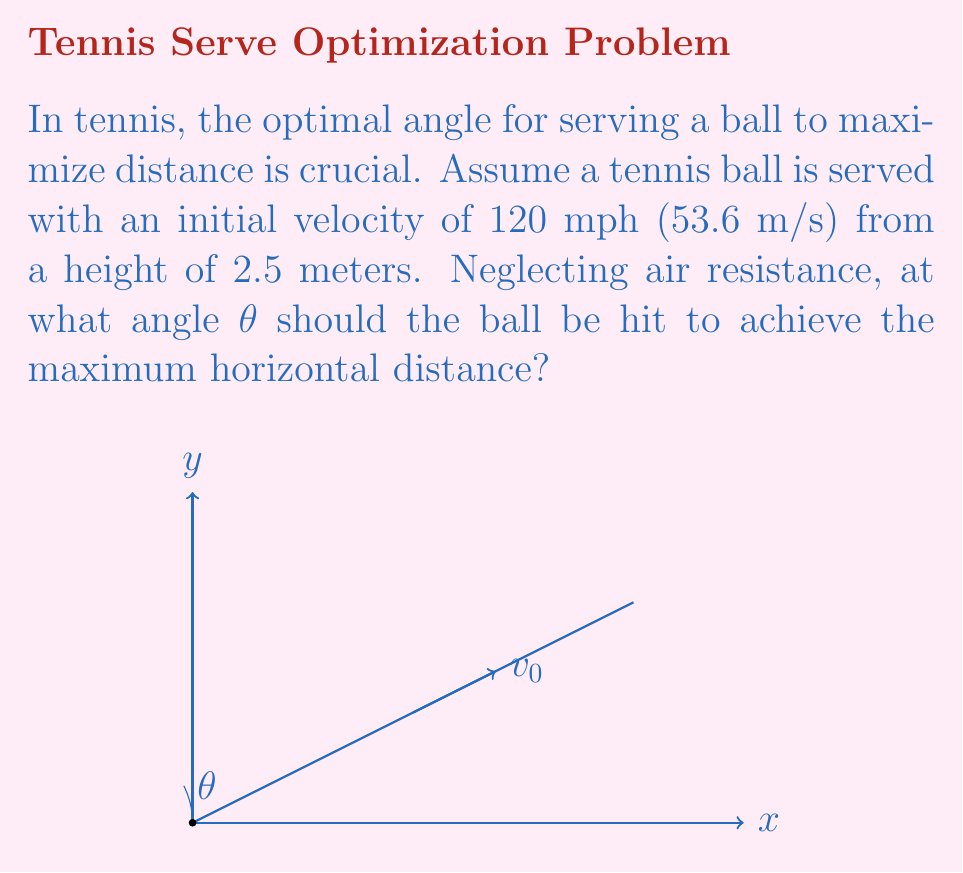Can you solve this math problem? Let's approach this step-by-step:

1) The range (R) of a projectile launched from height h with initial velocity v₀ at an angle θ is given by:

   $$R = \frac{v_0 \cos θ}{g} \left(v_0 \sin θ + \sqrt{(v_0 \sin θ)^2 + 2gh}\right)$$

   where g is the acceleration due to gravity (9.8 m/s²).

2) To find the maximum range, we need to find the value of θ that maximizes R. We can do this by taking the derivative of R with respect to θ and setting it to zero.

3) However, this leads to a complex equation. Instead, we can use a known result: when the initial height is zero, the optimal angle is 45°. When there's an initial height, the optimal angle is slightly less than 45°.

4) We can use the approximation:

   $$θ_{optimal} ≈ 45° - \frac{1}{2} \arctan \left(\frac{4h}{R_0}\right)$$

   where R₀ is the range when θ = 45° and h = 0.

5) First, let's calculate R₀:
   $$R_0 = \frac{v_0^2}{g} = \frac{(53.6)^2}{9.8} ≈ 293.2 \text{ m}$$

6) Now we can calculate θ:
   $$θ_{optimal} ≈ 45° - \frac{1}{2} \arctan \left(\frac{4(2.5)}{293.2}\right) ≈ 44.4°$$

Therefore, the optimal angle for serving the tennis ball to maximize distance is approximately 44.4°.
Answer: $44.4°$ 